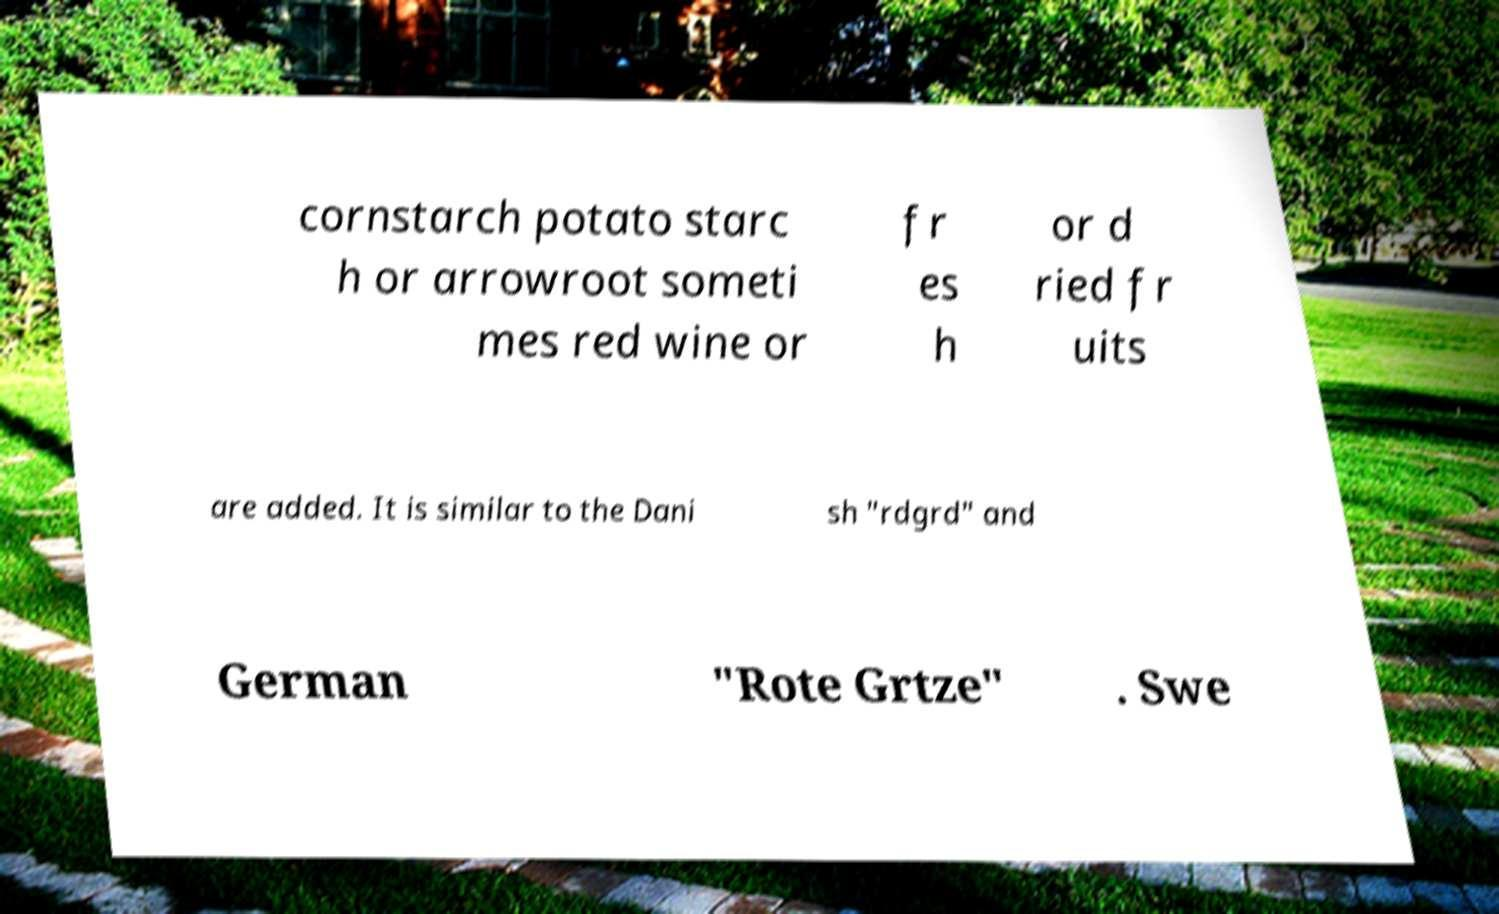Can you accurately transcribe the text from the provided image for me? cornstarch potato starc h or arrowroot someti mes red wine or fr es h or d ried fr uits are added. It is similar to the Dani sh "rdgrd" and German "Rote Grtze" . Swe 